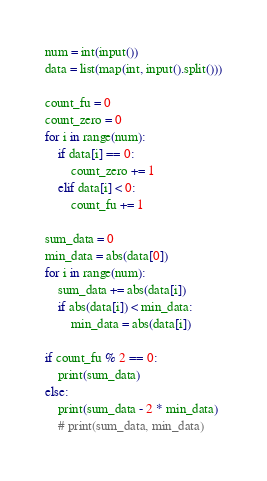<code> <loc_0><loc_0><loc_500><loc_500><_Python_>
num = int(input())
data = list(map(int, input().split()))

count_fu = 0
count_zero = 0
for i in range(num):
    if data[i] == 0:
        count_zero += 1
    elif data[i] < 0:
        count_fu += 1

sum_data = 0
min_data = abs(data[0])
for i in range(num):
    sum_data += abs(data[i])
    if abs(data[i]) < min_data:
        min_data = abs(data[i])

if count_fu % 2 == 0:
    print(sum_data)
else:
    print(sum_data - 2 * min_data)
    # print(sum_data, min_data)


</code> 